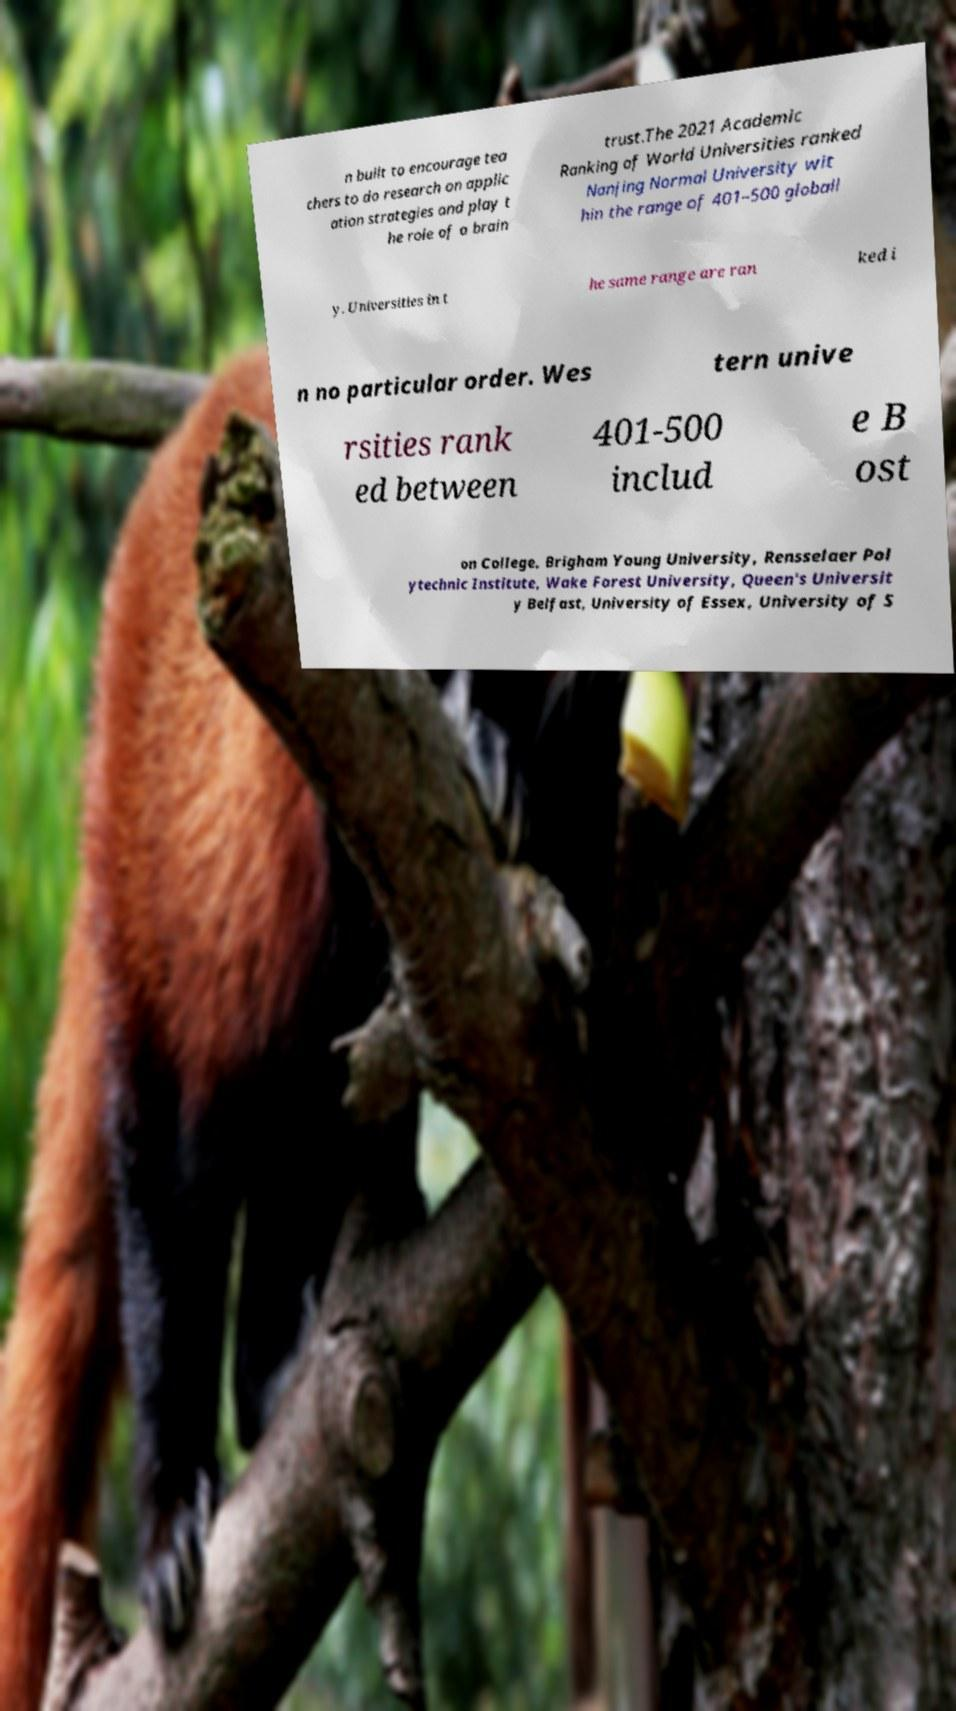There's text embedded in this image that I need extracted. Can you transcribe it verbatim? n built to encourage tea chers to do research on applic ation strategies and play t he role of a brain trust.The 2021 Academic Ranking of World Universities ranked Nanjing Normal University wit hin the range of 401–500 globall y. Universities in t he same range are ran ked i n no particular order. Wes tern unive rsities rank ed between 401-500 includ e B ost on College, Brigham Young University, Rensselaer Pol ytechnic Institute, Wake Forest University, Queen's Universit y Belfast, University of Essex, University of S 